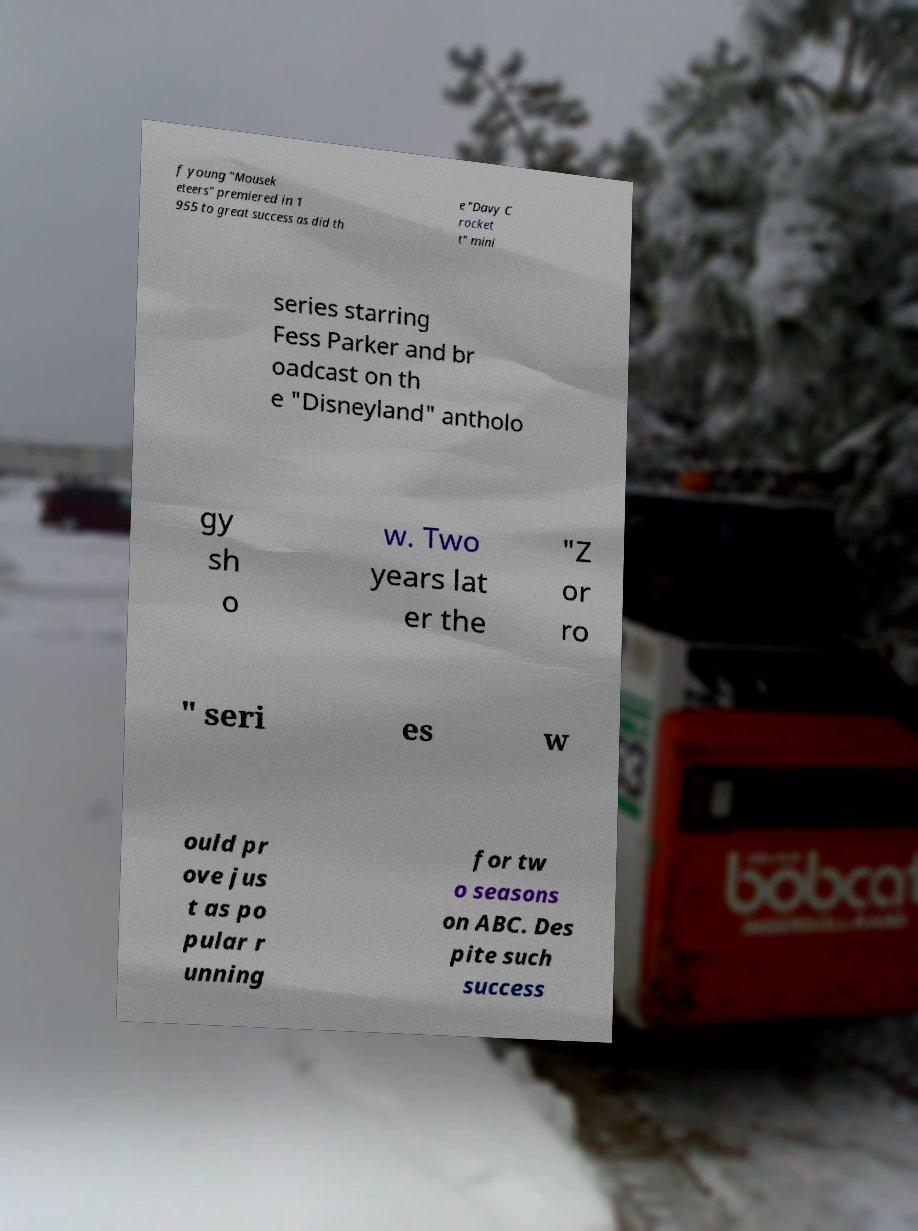What messages or text are displayed in this image? I need them in a readable, typed format. f young "Mousek eteers" premiered in 1 955 to great success as did th e "Davy C rocket t" mini series starring Fess Parker and br oadcast on th e "Disneyland" antholo gy sh o w. Two years lat er the "Z or ro " seri es w ould pr ove jus t as po pular r unning for tw o seasons on ABC. Des pite such success 